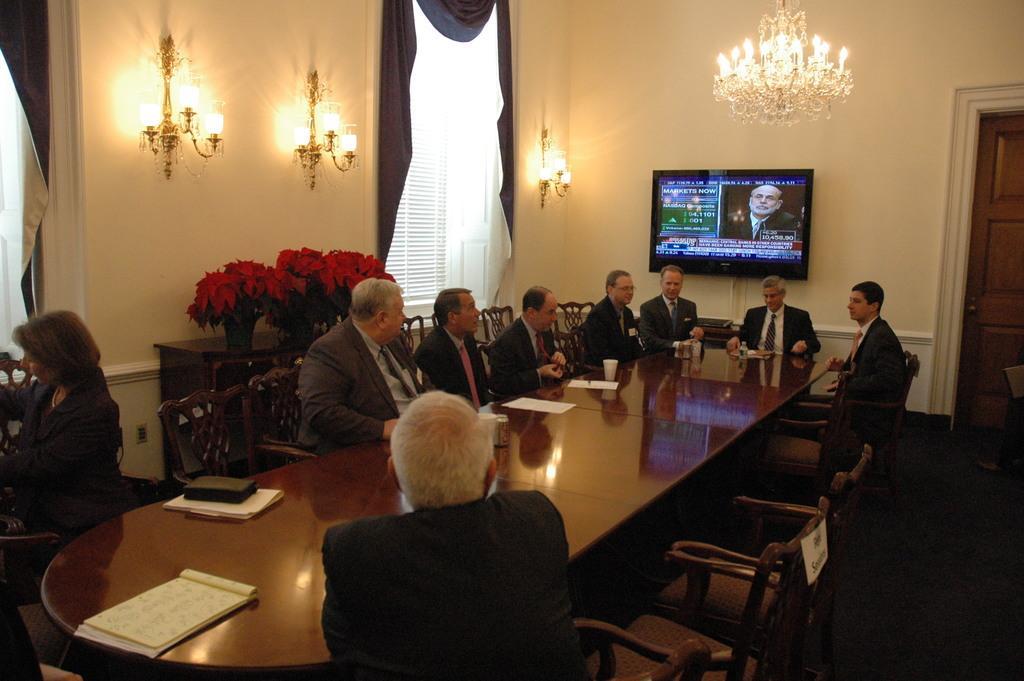Can you describe this image briefly? We can see lights, television over a wall. These are windows and curtains. Here we can see persons sitting on chairs in front of a table and on the table we can see glasses, papers, book. We can see flower pots on a table. This is a floor. This is a door. 